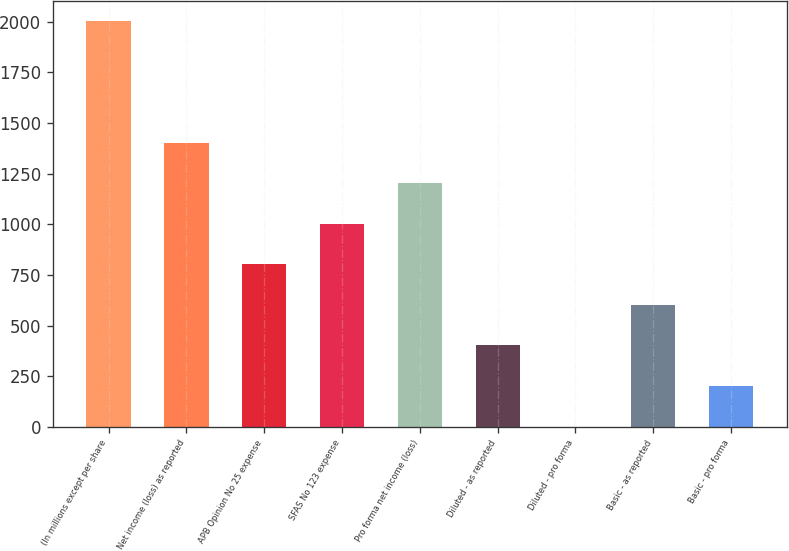<chart> <loc_0><loc_0><loc_500><loc_500><bar_chart><fcel>(In millions except per share<fcel>Net income (loss) as reported<fcel>APB Opinion No 25 expense<fcel>SFAS No 123 expense<fcel>Pro forma net income (loss)<fcel>Diluted - as reported<fcel>Diluted - pro forma<fcel>Basic - as reported<fcel>Basic - pro forma<nl><fcel>2004<fcel>1403.25<fcel>802.5<fcel>1002.75<fcel>1203<fcel>402<fcel>1.5<fcel>602.25<fcel>201.75<nl></chart> 